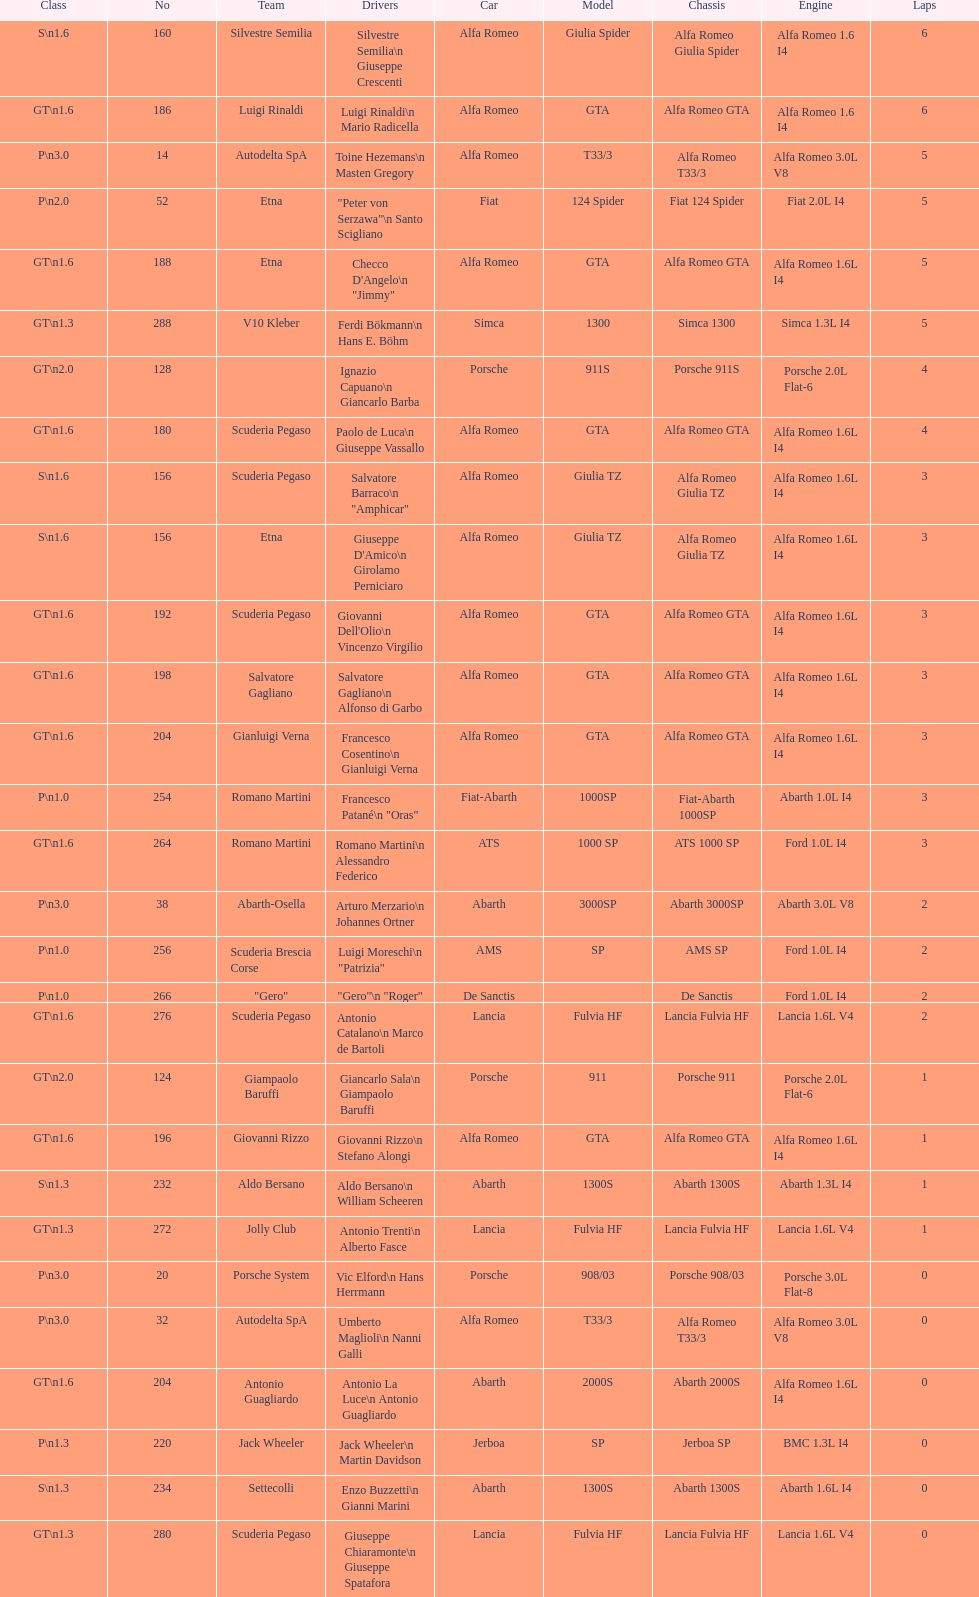What is the lap count for the v10 kleber? 5. 